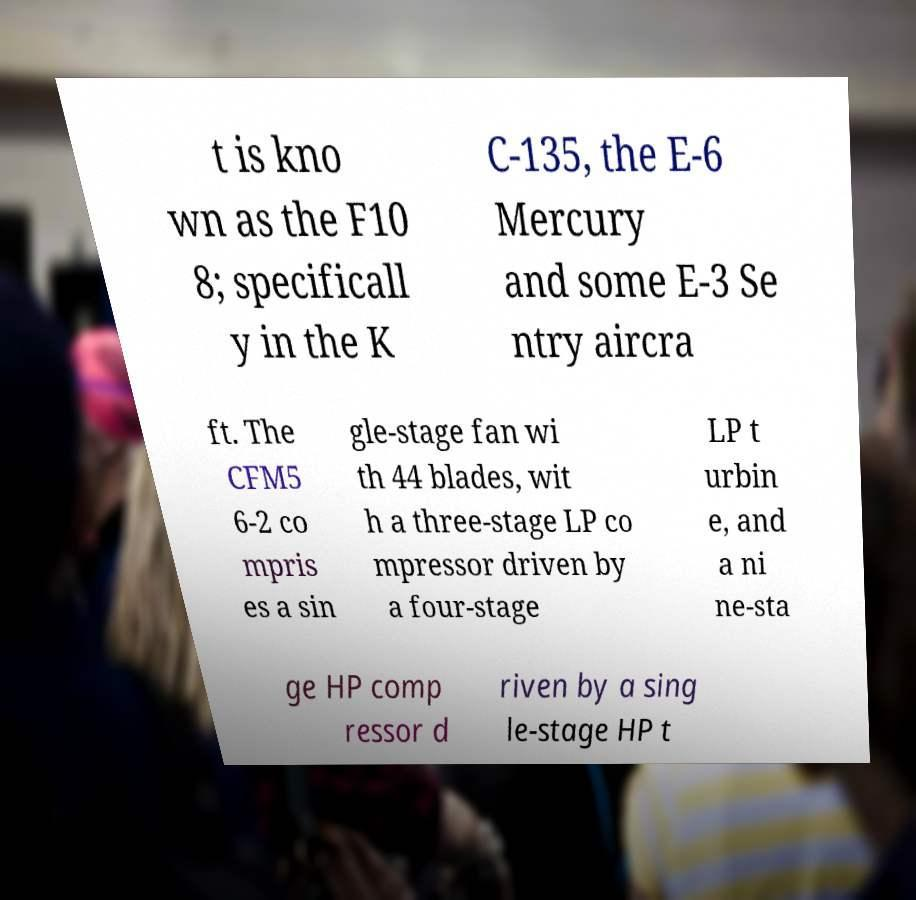Could you assist in decoding the text presented in this image and type it out clearly? t is kno wn as the F10 8; specificall y in the K C-135, the E-6 Mercury and some E-3 Se ntry aircra ft. The CFM5 6-2 co mpris es a sin gle-stage fan wi th 44 blades, wit h a three-stage LP co mpressor driven by a four-stage LP t urbin e, and a ni ne-sta ge HP comp ressor d riven by a sing le-stage HP t 